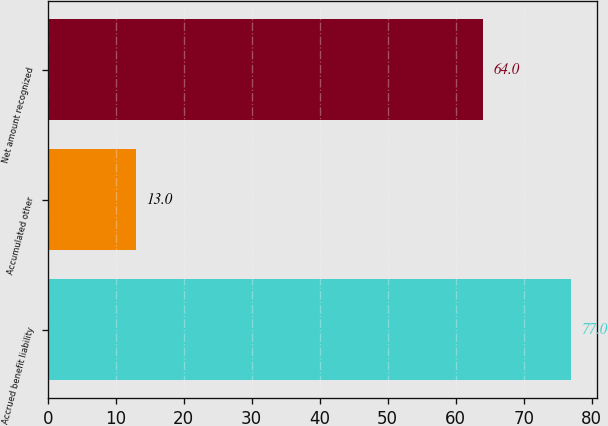Convert chart. <chart><loc_0><loc_0><loc_500><loc_500><bar_chart><fcel>Accrued benefit liability<fcel>Accumulated other<fcel>Net amount recognized<nl><fcel>77<fcel>13<fcel>64<nl></chart> 